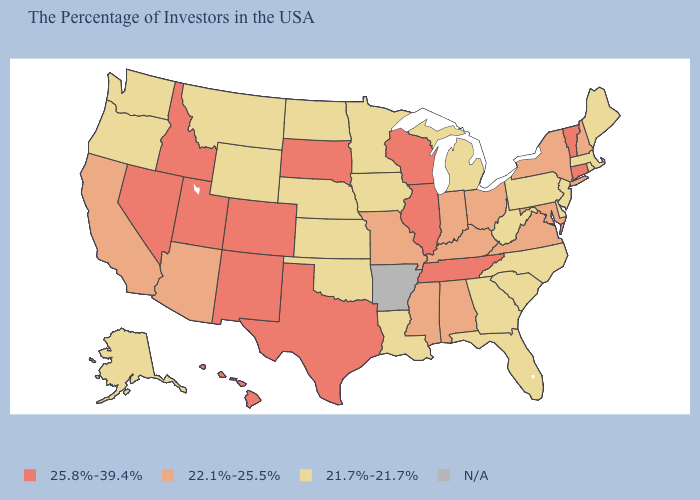Which states hav the highest value in the Northeast?
Short answer required. Vermont, Connecticut. What is the lowest value in states that border Connecticut?
Concise answer only. 21.7%-21.7%. What is the value of Virginia?
Concise answer only. 22.1%-25.5%. What is the value of Connecticut?
Give a very brief answer. 25.8%-39.4%. Is the legend a continuous bar?
Answer briefly. No. Among the states that border Kansas , which have the lowest value?
Give a very brief answer. Nebraska, Oklahoma. Name the states that have a value in the range 25.8%-39.4%?
Concise answer only. Vermont, Connecticut, Tennessee, Wisconsin, Illinois, Texas, South Dakota, Colorado, New Mexico, Utah, Idaho, Nevada, Hawaii. Name the states that have a value in the range 21.7%-21.7%?
Keep it brief. Maine, Massachusetts, Rhode Island, New Jersey, Delaware, Pennsylvania, North Carolina, South Carolina, West Virginia, Florida, Georgia, Michigan, Louisiana, Minnesota, Iowa, Kansas, Nebraska, Oklahoma, North Dakota, Wyoming, Montana, Washington, Oregon, Alaska. Does Colorado have the lowest value in the USA?
Short answer required. No. What is the value of Connecticut?
Be succinct. 25.8%-39.4%. Does Wyoming have the lowest value in the USA?
Write a very short answer. Yes. Name the states that have a value in the range 22.1%-25.5%?
Keep it brief. New Hampshire, New York, Maryland, Virginia, Ohio, Kentucky, Indiana, Alabama, Mississippi, Missouri, Arizona, California. Among the states that border Indiana , which have the highest value?
Give a very brief answer. Illinois. What is the value of North Carolina?
Concise answer only. 21.7%-21.7%. Among the states that border Louisiana , does Texas have the highest value?
Concise answer only. Yes. 